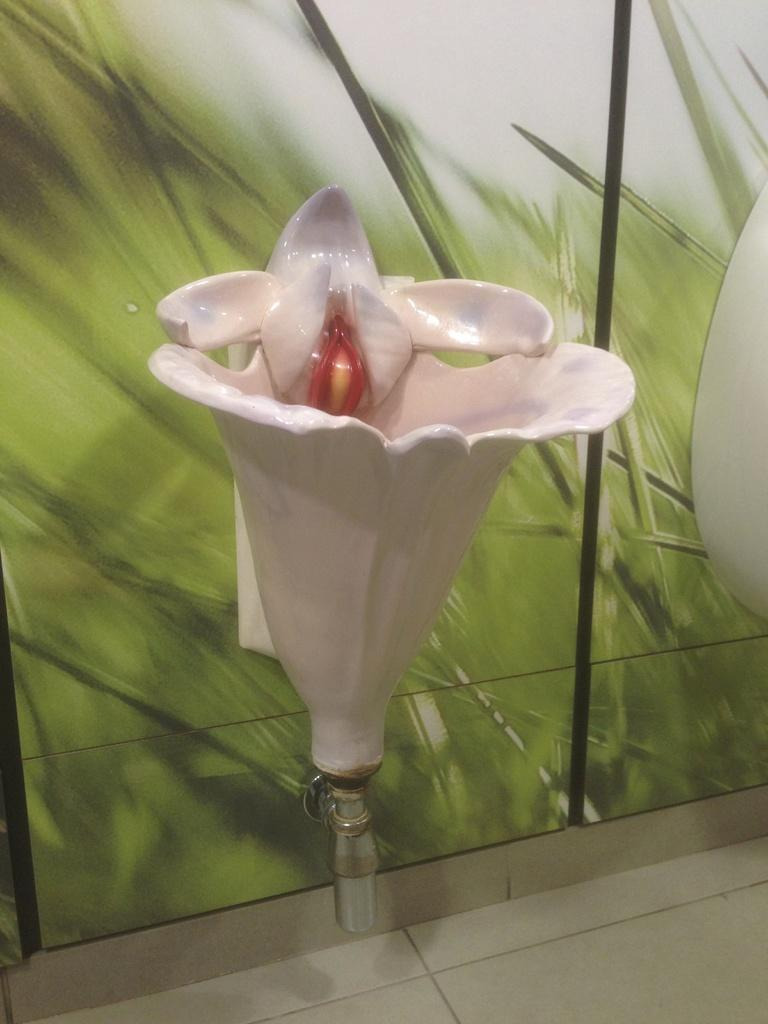What type of object is in the image? There is a ceramic object in the image. Can you describe the colors of the ceramic object? The ceramic object has cream and red colors. What colors are present in the background of the image? The background of the image has green and ash colors. How many ducks are swimming in the rainstorm depicted in the image? There are no ducks or rainstorm present in the image; it features a ceramic object with a specific color scheme and a background with different colors. 